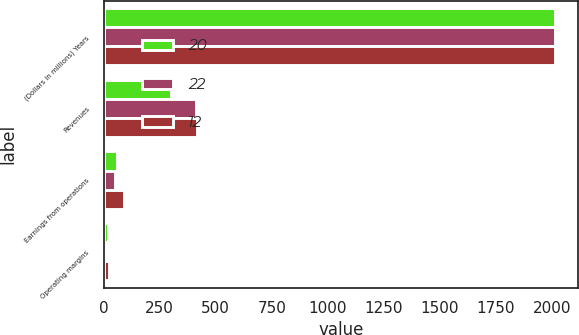Convert chart to OTSL. <chart><loc_0><loc_0><loc_500><loc_500><stacked_bar_chart><ecel><fcel>(Dollars in millions) Years<fcel>Revenues<fcel>Earnings from operations<fcel>Operating margins<nl><fcel>20<fcel>2016<fcel>298<fcel>59<fcel>20<nl><fcel>22<fcel>2015<fcel>413<fcel>50<fcel>12<nl><fcel>12<fcel>2014<fcel>416<fcel>92<fcel>22<nl></chart> 